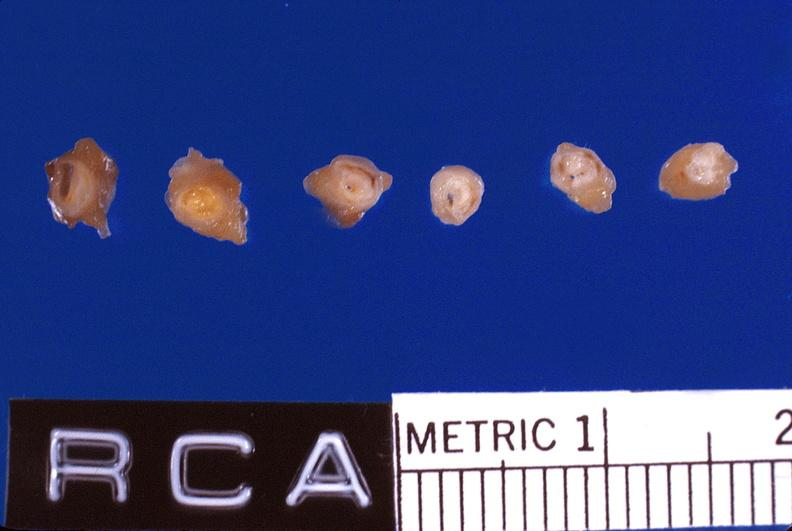does carcinomatosis show atherosclerosis, right coronary artery?
Answer the question using a single word or phrase. No 